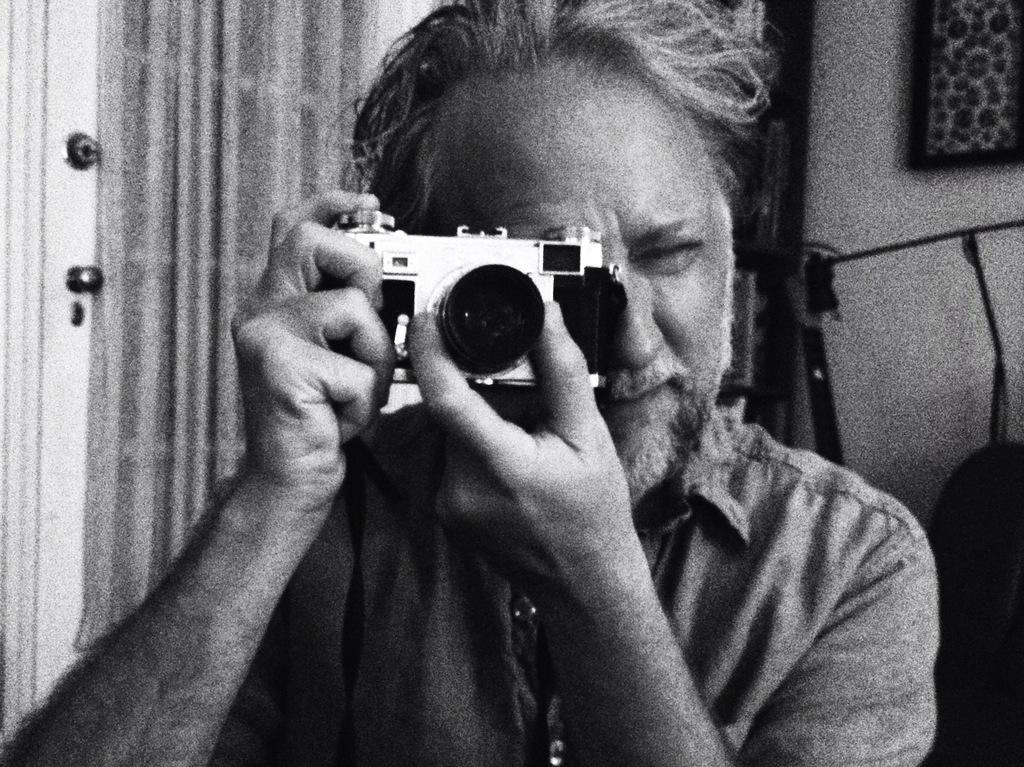What is the man in the image doing? The man is taking a picture in the image. What is the man holding while taking the picture? The man is holding a camera in the image. What can be seen in the background of the image? There is a door in the background of the image. Is there any decoration or object on the wall in the image? Yes, there is a photo frame on the wall in the image. What type of animal can be seen wearing a ring in the image? There is no animal wearing a ring present in the image. How does the wind affect the man taking a picture in the image? There is no mention of wind in the image, so its effect on the man cannot be determined. 